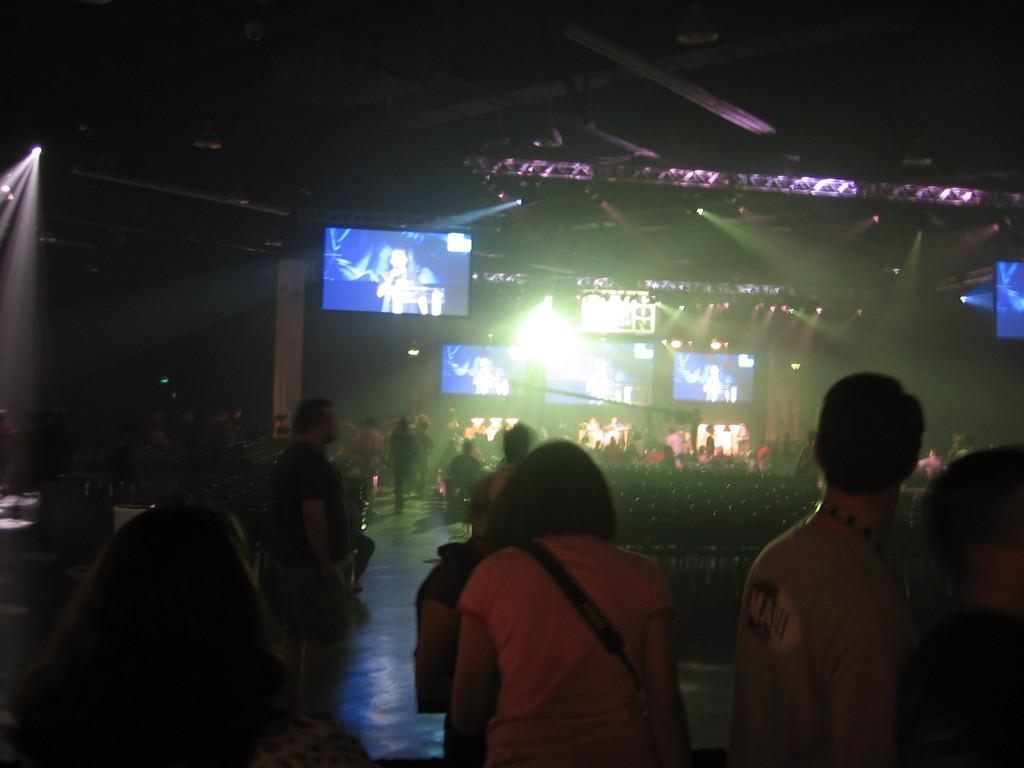How would you summarize this image in a sentence or two? In the foreground of the image we can see some people are standing. In the middle of the image we can see screens and some crowd. On the top of the image we can see iron rod and darkness. 